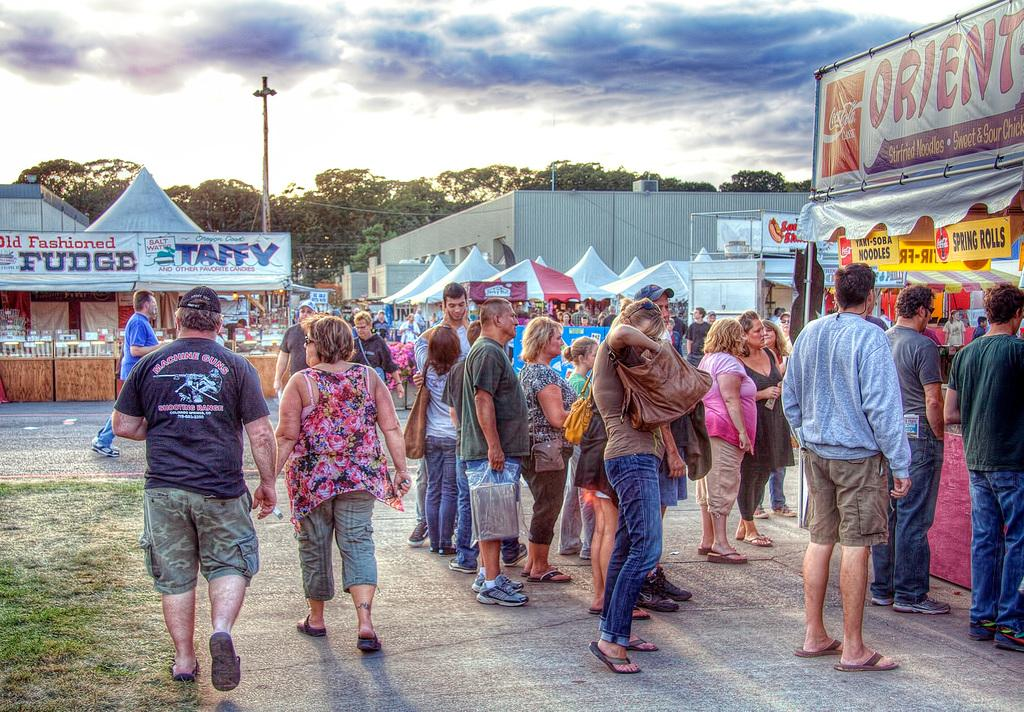Where was the image taken? The image is taken outside. What can be seen in the middle of the image? There are stalls and people standing in the middle of the image. What is visible at the top of the image? The sky is visible at the top of the image. What type of cherry is being sold at the top of the image? There is no cherry present in the image; the image only shows stalls and people standing in the middle, with the sky visible at the top. 